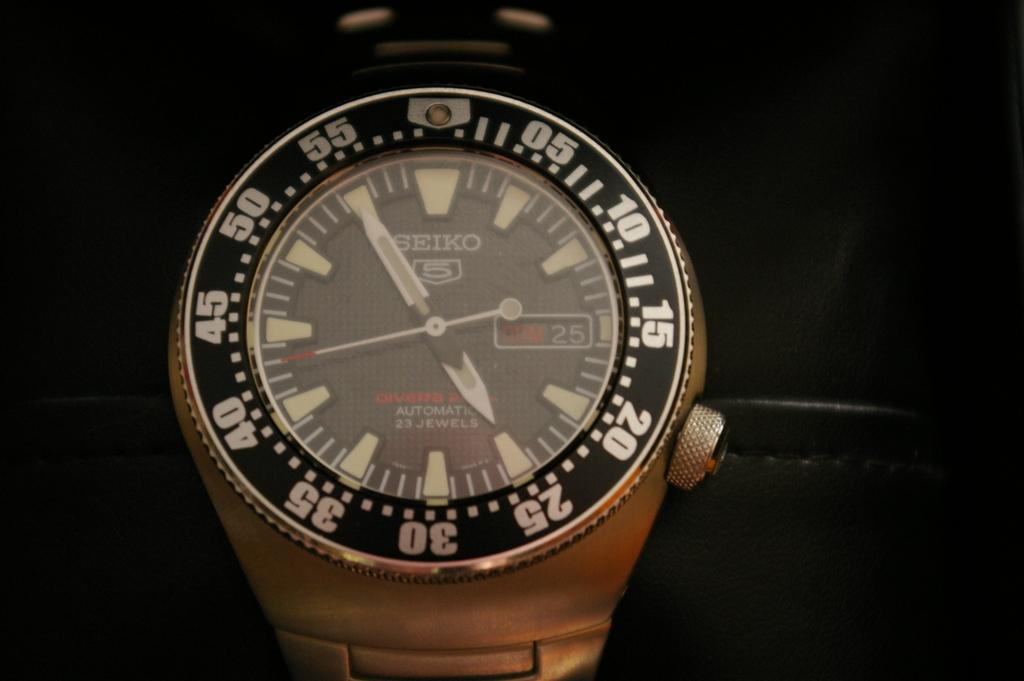<image>
Give a short and clear explanation of the subsequent image. A silver and black watch says "SEIKO" on the face. 